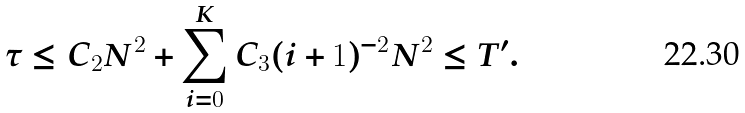<formula> <loc_0><loc_0><loc_500><loc_500>\tau \leq C _ { 2 } N ^ { 2 } + \sum _ { i = 0 } ^ { K } C _ { 3 } ( i + 1 ) ^ { - 2 } N ^ { 2 } \leq T ^ { \prime } .</formula> 